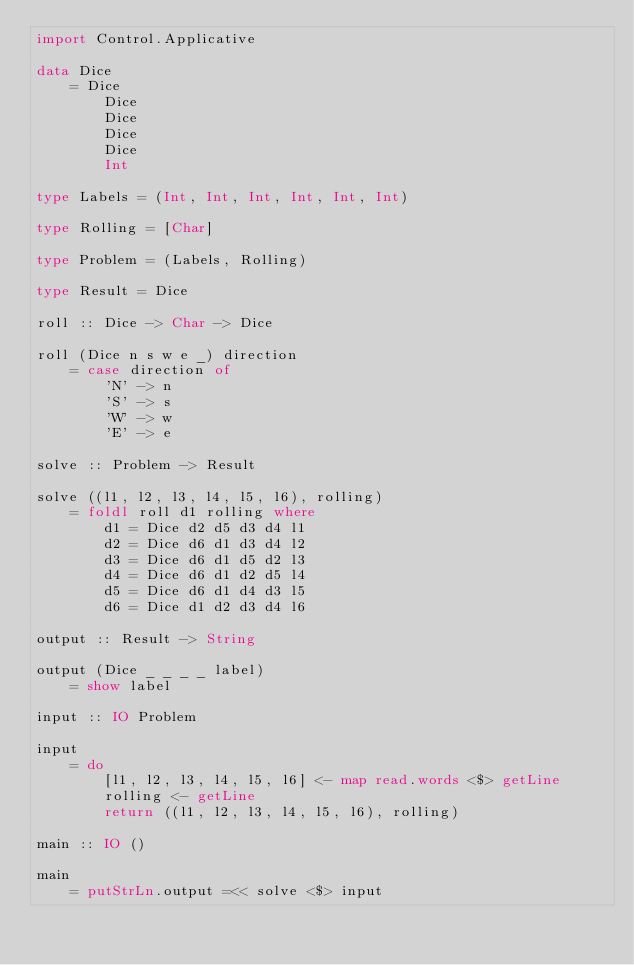<code> <loc_0><loc_0><loc_500><loc_500><_Haskell_>import Control.Applicative

data Dice
    = Dice
        Dice
        Dice
        Dice
        Dice
        Int

type Labels = (Int, Int, Int, Int, Int, Int)

type Rolling = [Char]

type Problem = (Labels, Rolling)

type Result = Dice

roll :: Dice -> Char -> Dice

roll (Dice n s w e _) direction
    = case direction of
        'N' -> n
        'S' -> s
        'W' -> w
        'E' -> e

solve :: Problem -> Result

solve ((l1, l2, l3, l4, l5, l6), rolling)
    = foldl roll d1 rolling where
        d1 = Dice d2 d5 d3 d4 l1
        d2 = Dice d6 d1 d3 d4 l2
        d3 = Dice d6 d1 d5 d2 l3
        d4 = Dice d6 d1 d2 d5 l4
        d5 = Dice d6 d1 d4 d3 l5
        d6 = Dice d1 d2 d3 d4 l6

output :: Result -> String

output (Dice _ _ _ _ label)
    = show label
    
input :: IO Problem

input
    = do
        [l1, l2, l3, l4, l5, l6] <- map read.words <$> getLine
        rolling <- getLine
        return ((l1, l2, l3, l4, l5, l6), rolling)

main :: IO ()

main
    = putStrLn.output =<< solve <$> input</code> 